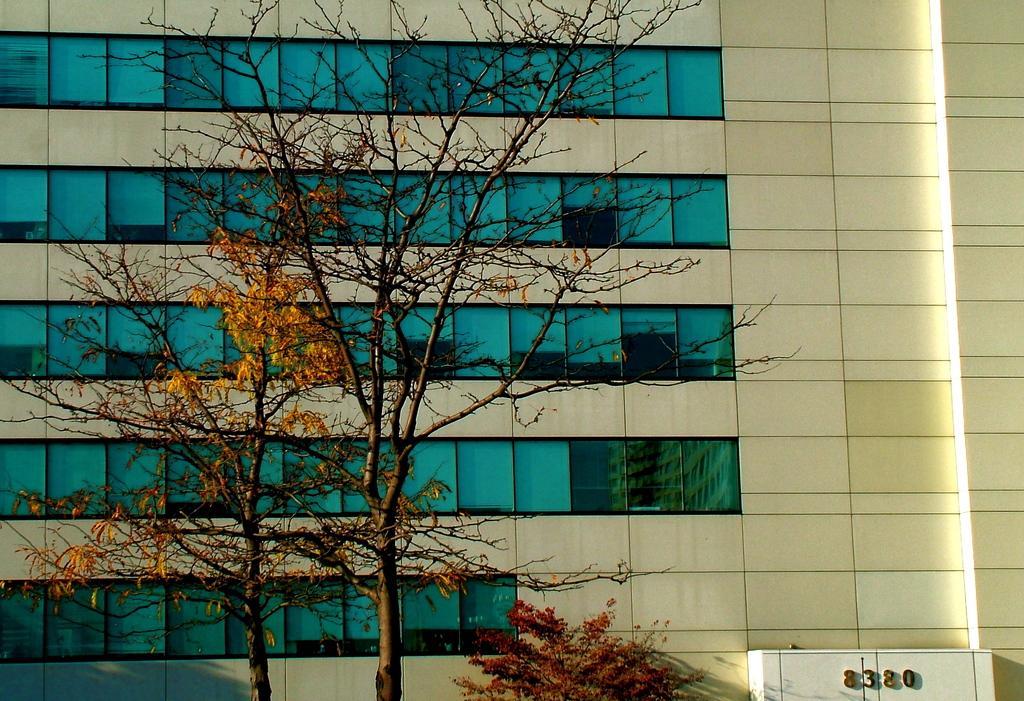In one or two sentences, can you explain what this image depicts? This image consists of a building along with windows. In the front, there is a tree. 